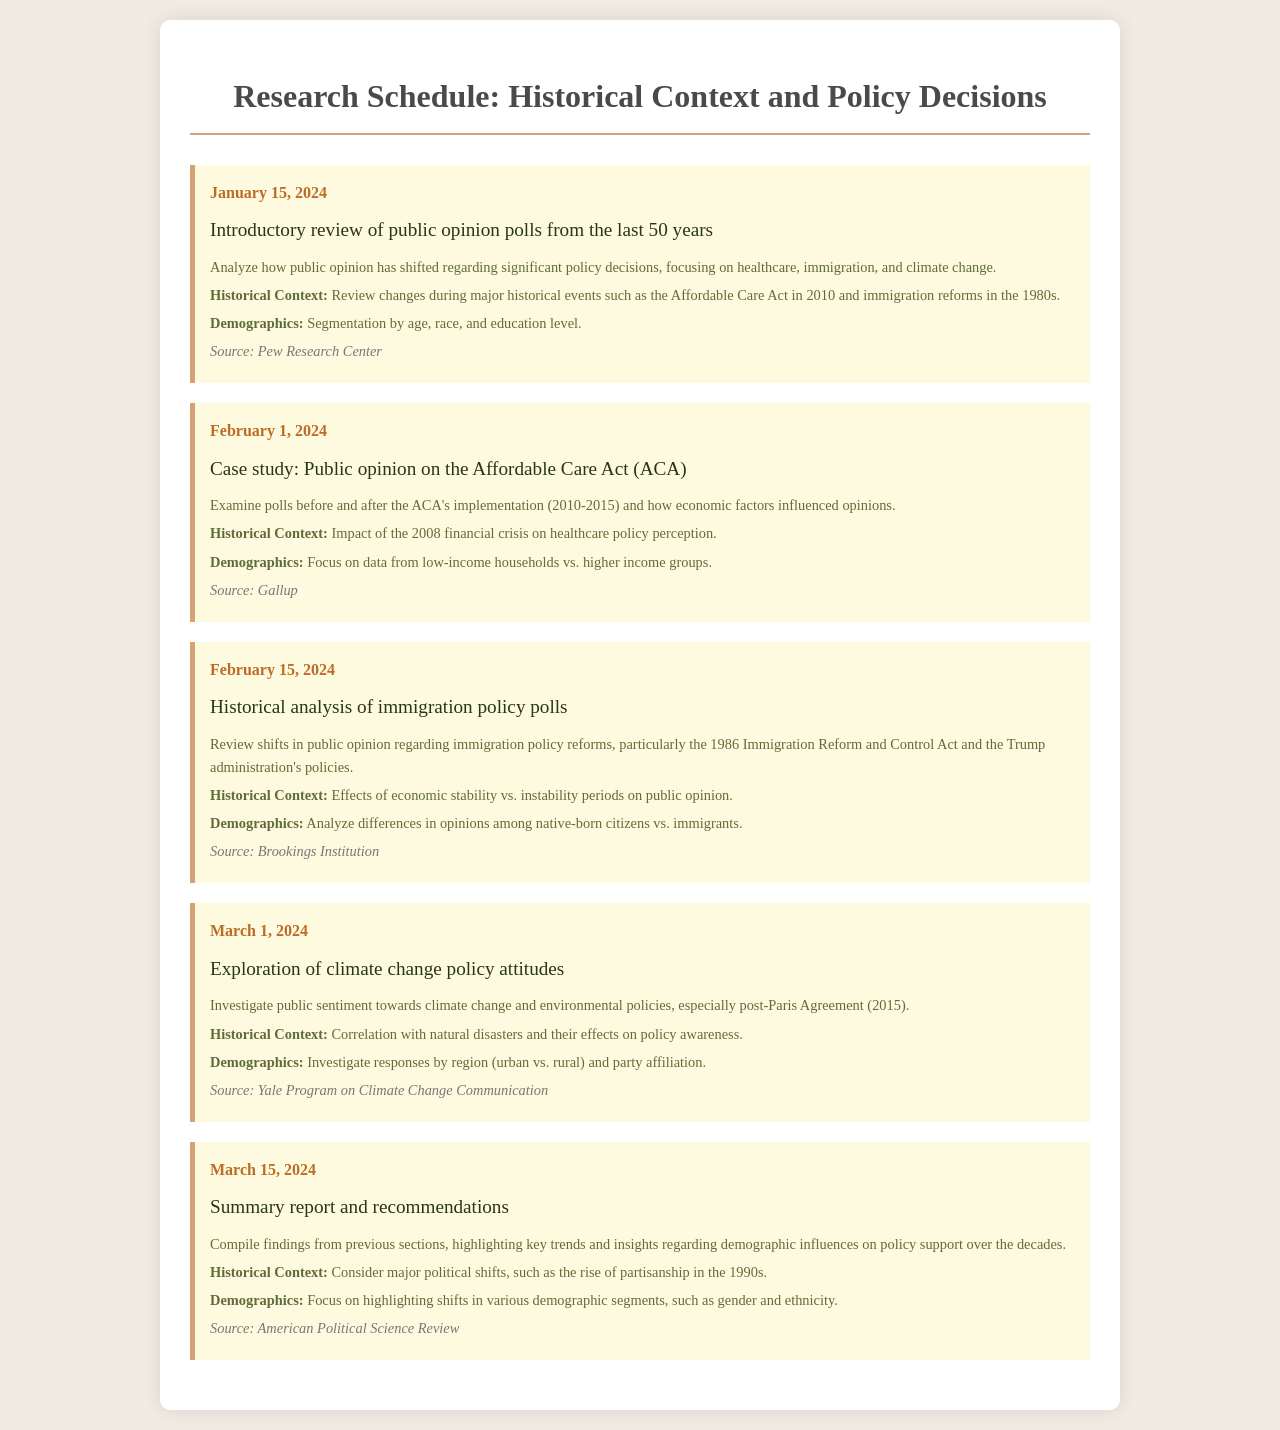What is the date of the introductory review of public opinion polls? The date is specified in the schedule as January 15, 2024.
Answer: January 15, 2024 What major healthcare policy is examined in the February 1, 2024 task? The task focuses on the Affordable Care Act (ACA) implemented in 2010.
Answer: Affordable Care Act Which historical event is linked to the analysis of the ACA? The 2008 financial crisis is mentioned in the context of its impact on healthcare perceptions.
Answer: 2008 financial crisis What demographic factors are analyzed in the immigration policy polls on February 15, 2024? The analysis focuses on differences in opinions among native-born citizens and immigrants.
Answer: Native-born citizens vs. immigrants What is the primary source for the exploration of climate change policy attitudes on March 1, 2024? The source cited for this exploration is the Yale Program on Climate Change Communication.
Answer: Yale Program on Climate Change Communication What is the main task on March 15, 2024? The task is to compile findings and highlight key trends regarding demographic influences on policy support.
Answer: Summary report and recommendations Which significant act is mentioned in relation to immigration policy shifts? The 1986 Immigration Reform and Control Act is discussed regarding public opinion shifts.
Answer: 1986 Immigration Reform and Control Act What feature of public opinion is emphasized in the introductory review? The emphasis is on how public opinion has shifted regarding significant policy decisions.
Answer: Public opinion shifts What area is particularly analyzed for attitudes towards climate change policies? The analysis investigates responses by region, specifically urban vs. rural areas.
Answer: Urban vs. rural 